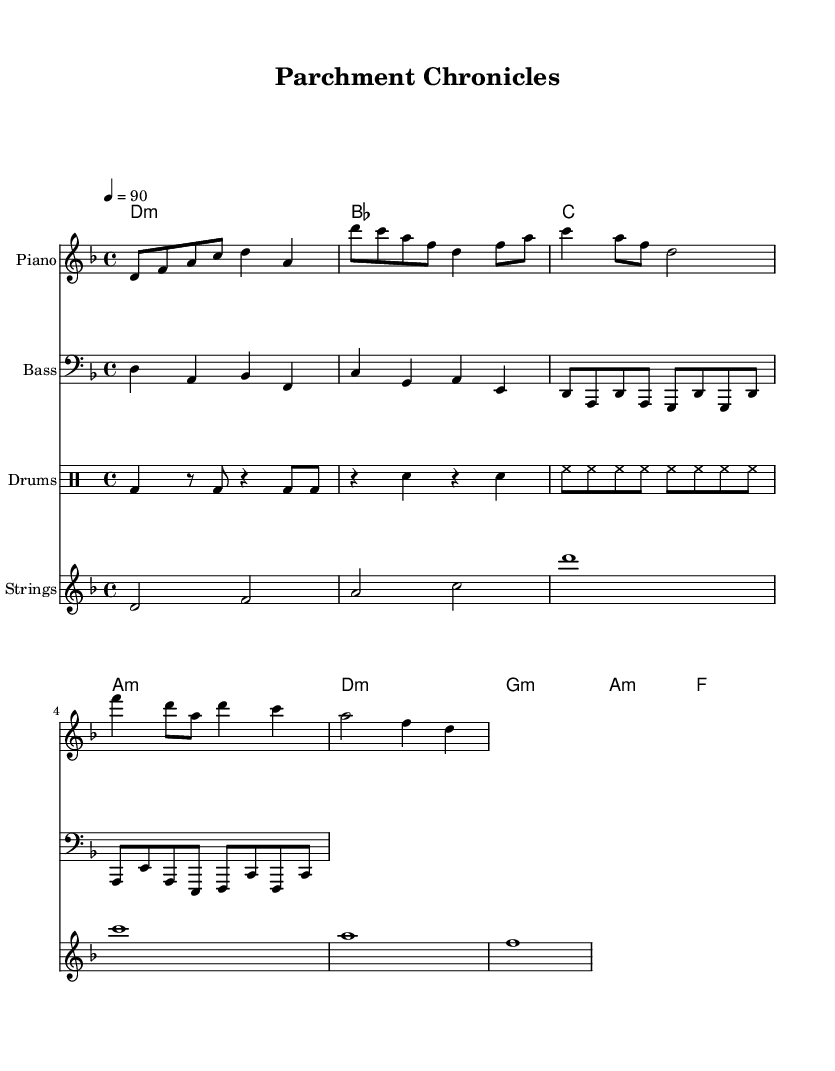what is the key signature of this music? The key signature is D minor, indicated by one flat (B flat) shown at the beginning of the staff.
Answer: D minor what is the time signature of this music? The time signature is 4/4, which is shown at the beginning of the score as a fraction with four beats in a measure and a quarter note as the beat unit.
Answer: 4/4 what is the tempo marking indicated in the sheet music? The tempo marking is 90 beats per minute (BPM), shown next to the tempo indication that establishes the speed at which the piece should be played.
Answer: 90 how many measures are in the verse section? The verse section contains four measures as indicated by counting the measures between the repeated structures in the music notation.
Answer: 4 what is the primary instrumental accompaniment in the chorus? The primary instrumental accompaniment in the chorus is the strings, which play sustained notes. This is demonstrated by the longer note values indicated in the score during that section.
Answer: Strings how many different instruments are used in this piece of sheet music? There are four different instruments used in this piece: piano, bass, drums, and strings, as indicated by the separate staves and their respective designations in the score.
Answer: Four what type of musical form does this hip hop piece primarily use? The hip hop piece utilizes a verse-chorus form, where the verse is followed by a repeated chorus, a common structure in hip hop, providing both variation and familiar hooks to the listener.
Answer: Verse-chorus 